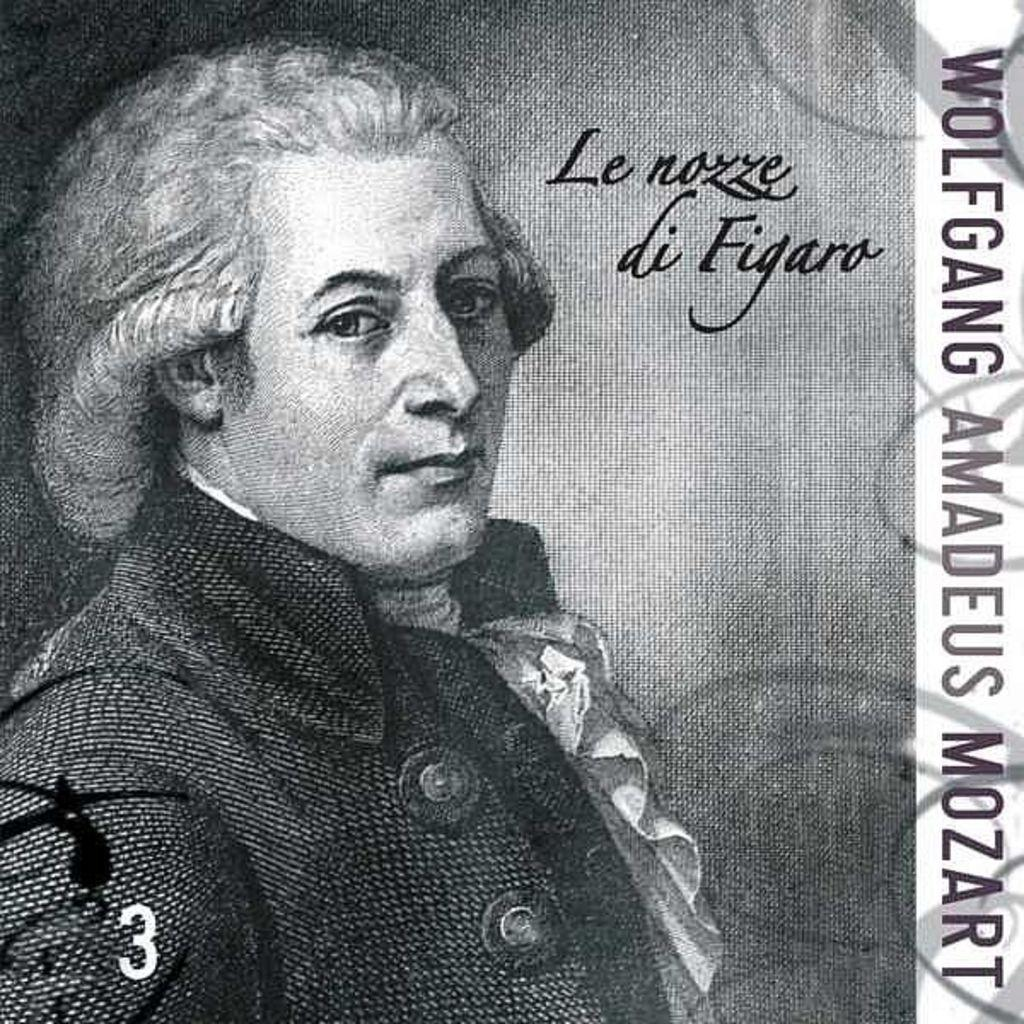What is the main object in the image? There is a banner in the image. What is depicted on the banner? The banner has a man wearing a black color jacket. What is the color scheme of the image? The image is in black and white. Can you tell me how many mothers are present in the image? There is no mother present in the image; it only features a banner with a man wearing a black color jacket. What type of hand can be seen holding the banner in the image? There is no hand holding the banner in the image; it is hanging or displayed on its own. 